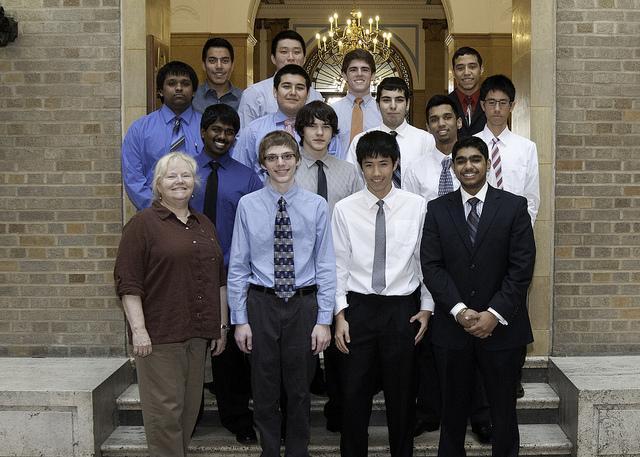How many women are in this photo?
Give a very brief answer. 1. How many people are wearing jackets?
Give a very brief answer. 2. How many people are in this scene?
Give a very brief answer. 15. How many people are in this picture?
Give a very brief answer. 15. How many people can be seen?
Give a very brief answer. 14. 